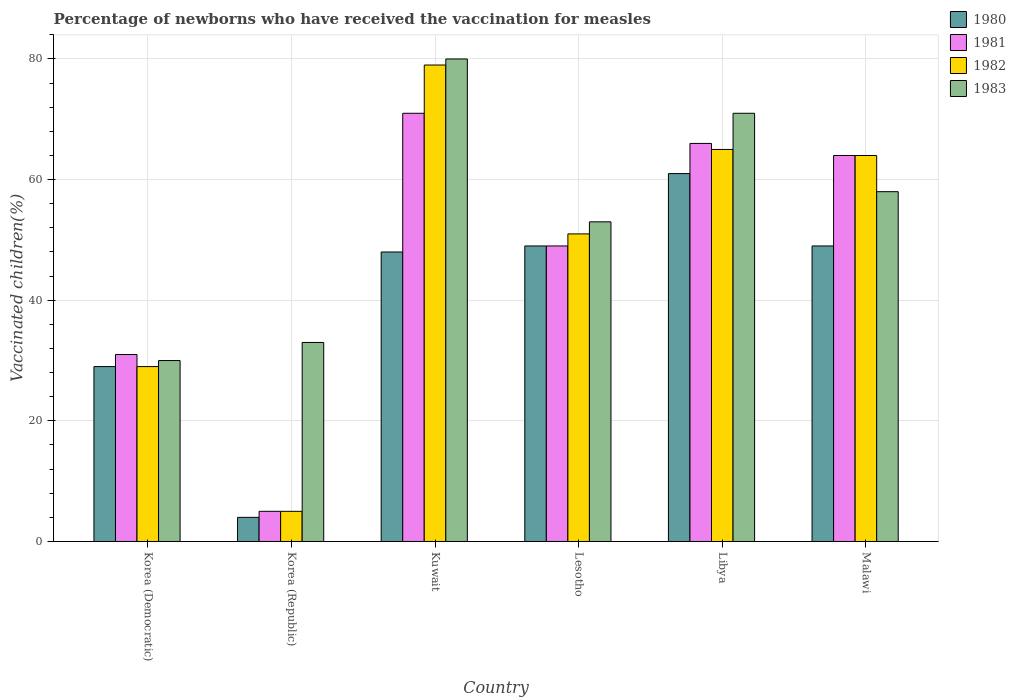How many different coloured bars are there?
Your response must be concise. 4. How many bars are there on the 6th tick from the right?
Your answer should be very brief. 4. What is the label of the 4th group of bars from the left?
Offer a very short reply. Lesotho. In how many cases, is the number of bars for a given country not equal to the number of legend labels?
Your response must be concise. 0. What is the percentage of vaccinated children in 1982 in Korea (Democratic)?
Provide a succinct answer. 29. Across all countries, what is the maximum percentage of vaccinated children in 1983?
Your answer should be compact. 80. In which country was the percentage of vaccinated children in 1982 maximum?
Your answer should be compact. Kuwait. What is the total percentage of vaccinated children in 1982 in the graph?
Ensure brevity in your answer.  293. What is the difference between the percentage of vaccinated children in 1982 in Korea (Democratic) and the percentage of vaccinated children in 1981 in Kuwait?
Make the answer very short. -42. What is the average percentage of vaccinated children in 1980 per country?
Provide a succinct answer. 40. What is the difference between the percentage of vaccinated children of/in 1981 and percentage of vaccinated children of/in 1983 in Korea (Democratic)?
Give a very brief answer. 1. What is the ratio of the percentage of vaccinated children in 1981 in Korea (Republic) to that in Lesotho?
Your answer should be compact. 0.1. Is the percentage of vaccinated children in 1980 in Korea (Democratic) less than that in Lesotho?
Offer a very short reply. Yes. Is the difference between the percentage of vaccinated children in 1981 in Korea (Democratic) and Kuwait greater than the difference between the percentage of vaccinated children in 1983 in Korea (Democratic) and Kuwait?
Make the answer very short. Yes. In how many countries, is the percentage of vaccinated children in 1982 greater than the average percentage of vaccinated children in 1982 taken over all countries?
Provide a short and direct response. 4. Is the sum of the percentage of vaccinated children in 1983 in Lesotho and Malawi greater than the maximum percentage of vaccinated children in 1981 across all countries?
Ensure brevity in your answer.  Yes. Is it the case that in every country, the sum of the percentage of vaccinated children in 1980 and percentage of vaccinated children in 1982 is greater than the percentage of vaccinated children in 1981?
Give a very brief answer. Yes. Are all the bars in the graph horizontal?
Keep it short and to the point. No. What is the difference between two consecutive major ticks on the Y-axis?
Your answer should be very brief. 20. Where does the legend appear in the graph?
Your answer should be very brief. Top right. How many legend labels are there?
Provide a succinct answer. 4. How are the legend labels stacked?
Offer a terse response. Vertical. What is the title of the graph?
Make the answer very short. Percentage of newborns who have received the vaccination for measles. What is the label or title of the Y-axis?
Your response must be concise. Vaccinated children(%). What is the Vaccinated children(%) in 1980 in Korea (Republic)?
Provide a short and direct response. 4. What is the Vaccinated children(%) of 1982 in Korea (Republic)?
Your answer should be compact. 5. What is the Vaccinated children(%) in 1982 in Kuwait?
Ensure brevity in your answer.  79. What is the Vaccinated children(%) in 1983 in Kuwait?
Make the answer very short. 80. What is the Vaccinated children(%) in 1981 in Lesotho?
Ensure brevity in your answer.  49. What is the Vaccinated children(%) of 1982 in Lesotho?
Ensure brevity in your answer.  51. What is the Vaccinated children(%) of 1980 in Libya?
Your answer should be very brief. 61. What is the Vaccinated children(%) in 1981 in Libya?
Your answer should be compact. 66. What is the Vaccinated children(%) in 1980 in Malawi?
Give a very brief answer. 49. What is the Vaccinated children(%) of 1982 in Malawi?
Your response must be concise. 64. Across all countries, what is the maximum Vaccinated children(%) of 1981?
Your answer should be very brief. 71. Across all countries, what is the maximum Vaccinated children(%) in 1982?
Provide a succinct answer. 79. Across all countries, what is the maximum Vaccinated children(%) of 1983?
Give a very brief answer. 80. Across all countries, what is the minimum Vaccinated children(%) in 1981?
Ensure brevity in your answer.  5. Across all countries, what is the minimum Vaccinated children(%) in 1982?
Ensure brevity in your answer.  5. Across all countries, what is the minimum Vaccinated children(%) of 1983?
Offer a very short reply. 30. What is the total Vaccinated children(%) of 1980 in the graph?
Your response must be concise. 240. What is the total Vaccinated children(%) in 1981 in the graph?
Keep it short and to the point. 286. What is the total Vaccinated children(%) of 1982 in the graph?
Make the answer very short. 293. What is the total Vaccinated children(%) in 1983 in the graph?
Make the answer very short. 325. What is the difference between the Vaccinated children(%) in 1982 in Korea (Democratic) and that in Korea (Republic)?
Your answer should be compact. 24. What is the difference between the Vaccinated children(%) in 1980 in Korea (Democratic) and that in Kuwait?
Provide a succinct answer. -19. What is the difference between the Vaccinated children(%) in 1980 in Korea (Democratic) and that in Libya?
Your response must be concise. -32. What is the difference between the Vaccinated children(%) of 1981 in Korea (Democratic) and that in Libya?
Give a very brief answer. -35. What is the difference between the Vaccinated children(%) of 1982 in Korea (Democratic) and that in Libya?
Offer a terse response. -36. What is the difference between the Vaccinated children(%) of 1983 in Korea (Democratic) and that in Libya?
Your answer should be compact. -41. What is the difference between the Vaccinated children(%) of 1980 in Korea (Democratic) and that in Malawi?
Give a very brief answer. -20. What is the difference between the Vaccinated children(%) of 1981 in Korea (Democratic) and that in Malawi?
Offer a terse response. -33. What is the difference between the Vaccinated children(%) in 1982 in Korea (Democratic) and that in Malawi?
Keep it short and to the point. -35. What is the difference between the Vaccinated children(%) in 1983 in Korea (Democratic) and that in Malawi?
Provide a succinct answer. -28. What is the difference between the Vaccinated children(%) of 1980 in Korea (Republic) and that in Kuwait?
Your response must be concise. -44. What is the difference between the Vaccinated children(%) of 1981 in Korea (Republic) and that in Kuwait?
Offer a very short reply. -66. What is the difference between the Vaccinated children(%) in 1982 in Korea (Republic) and that in Kuwait?
Offer a very short reply. -74. What is the difference between the Vaccinated children(%) in 1983 in Korea (Republic) and that in Kuwait?
Ensure brevity in your answer.  -47. What is the difference between the Vaccinated children(%) in 1980 in Korea (Republic) and that in Lesotho?
Keep it short and to the point. -45. What is the difference between the Vaccinated children(%) in 1981 in Korea (Republic) and that in Lesotho?
Offer a very short reply. -44. What is the difference between the Vaccinated children(%) in 1982 in Korea (Republic) and that in Lesotho?
Make the answer very short. -46. What is the difference between the Vaccinated children(%) in 1983 in Korea (Republic) and that in Lesotho?
Your response must be concise. -20. What is the difference between the Vaccinated children(%) of 1980 in Korea (Republic) and that in Libya?
Provide a short and direct response. -57. What is the difference between the Vaccinated children(%) of 1981 in Korea (Republic) and that in Libya?
Ensure brevity in your answer.  -61. What is the difference between the Vaccinated children(%) in 1982 in Korea (Republic) and that in Libya?
Provide a succinct answer. -60. What is the difference between the Vaccinated children(%) of 1983 in Korea (Republic) and that in Libya?
Offer a terse response. -38. What is the difference between the Vaccinated children(%) of 1980 in Korea (Republic) and that in Malawi?
Offer a terse response. -45. What is the difference between the Vaccinated children(%) in 1981 in Korea (Republic) and that in Malawi?
Your answer should be compact. -59. What is the difference between the Vaccinated children(%) in 1982 in Korea (Republic) and that in Malawi?
Your answer should be compact. -59. What is the difference between the Vaccinated children(%) of 1983 in Korea (Republic) and that in Malawi?
Offer a very short reply. -25. What is the difference between the Vaccinated children(%) of 1982 in Kuwait and that in Lesotho?
Offer a terse response. 28. What is the difference between the Vaccinated children(%) in 1983 in Kuwait and that in Lesotho?
Give a very brief answer. 27. What is the difference between the Vaccinated children(%) of 1982 in Kuwait and that in Libya?
Provide a succinct answer. 14. What is the difference between the Vaccinated children(%) of 1980 in Kuwait and that in Malawi?
Your response must be concise. -1. What is the difference between the Vaccinated children(%) in 1981 in Kuwait and that in Malawi?
Provide a succinct answer. 7. What is the difference between the Vaccinated children(%) in 1982 in Kuwait and that in Malawi?
Provide a short and direct response. 15. What is the difference between the Vaccinated children(%) of 1983 in Kuwait and that in Malawi?
Provide a short and direct response. 22. What is the difference between the Vaccinated children(%) of 1980 in Lesotho and that in Libya?
Give a very brief answer. -12. What is the difference between the Vaccinated children(%) of 1982 in Lesotho and that in Malawi?
Ensure brevity in your answer.  -13. What is the difference between the Vaccinated children(%) of 1981 in Libya and that in Malawi?
Offer a terse response. 2. What is the difference between the Vaccinated children(%) in 1983 in Libya and that in Malawi?
Give a very brief answer. 13. What is the difference between the Vaccinated children(%) in 1980 in Korea (Democratic) and the Vaccinated children(%) in 1982 in Korea (Republic)?
Provide a short and direct response. 24. What is the difference between the Vaccinated children(%) in 1980 in Korea (Democratic) and the Vaccinated children(%) in 1983 in Korea (Republic)?
Make the answer very short. -4. What is the difference between the Vaccinated children(%) of 1981 in Korea (Democratic) and the Vaccinated children(%) of 1982 in Korea (Republic)?
Your answer should be compact. 26. What is the difference between the Vaccinated children(%) in 1981 in Korea (Democratic) and the Vaccinated children(%) in 1983 in Korea (Republic)?
Your answer should be very brief. -2. What is the difference between the Vaccinated children(%) of 1980 in Korea (Democratic) and the Vaccinated children(%) of 1981 in Kuwait?
Your response must be concise. -42. What is the difference between the Vaccinated children(%) in 1980 in Korea (Democratic) and the Vaccinated children(%) in 1983 in Kuwait?
Your response must be concise. -51. What is the difference between the Vaccinated children(%) in 1981 in Korea (Democratic) and the Vaccinated children(%) in 1982 in Kuwait?
Give a very brief answer. -48. What is the difference between the Vaccinated children(%) of 1981 in Korea (Democratic) and the Vaccinated children(%) of 1983 in Kuwait?
Provide a succinct answer. -49. What is the difference between the Vaccinated children(%) of 1982 in Korea (Democratic) and the Vaccinated children(%) of 1983 in Kuwait?
Your response must be concise. -51. What is the difference between the Vaccinated children(%) in 1980 in Korea (Democratic) and the Vaccinated children(%) in 1981 in Lesotho?
Keep it short and to the point. -20. What is the difference between the Vaccinated children(%) of 1980 in Korea (Democratic) and the Vaccinated children(%) of 1983 in Lesotho?
Your answer should be very brief. -24. What is the difference between the Vaccinated children(%) of 1980 in Korea (Democratic) and the Vaccinated children(%) of 1981 in Libya?
Give a very brief answer. -37. What is the difference between the Vaccinated children(%) in 1980 in Korea (Democratic) and the Vaccinated children(%) in 1982 in Libya?
Your answer should be compact. -36. What is the difference between the Vaccinated children(%) in 1980 in Korea (Democratic) and the Vaccinated children(%) in 1983 in Libya?
Offer a very short reply. -42. What is the difference between the Vaccinated children(%) in 1981 in Korea (Democratic) and the Vaccinated children(%) in 1982 in Libya?
Provide a short and direct response. -34. What is the difference between the Vaccinated children(%) in 1982 in Korea (Democratic) and the Vaccinated children(%) in 1983 in Libya?
Your answer should be compact. -42. What is the difference between the Vaccinated children(%) in 1980 in Korea (Democratic) and the Vaccinated children(%) in 1981 in Malawi?
Keep it short and to the point. -35. What is the difference between the Vaccinated children(%) in 1980 in Korea (Democratic) and the Vaccinated children(%) in 1982 in Malawi?
Offer a terse response. -35. What is the difference between the Vaccinated children(%) of 1980 in Korea (Democratic) and the Vaccinated children(%) of 1983 in Malawi?
Offer a terse response. -29. What is the difference between the Vaccinated children(%) of 1981 in Korea (Democratic) and the Vaccinated children(%) of 1982 in Malawi?
Make the answer very short. -33. What is the difference between the Vaccinated children(%) of 1981 in Korea (Democratic) and the Vaccinated children(%) of 1983 in Malawi?
Offer a terse response. -27. What is the difference between the Vaccinated children(%) of 1980 in Korea (Republic) and the Vaccinated children(%) of 1981 in Kuwait?
Provide a short and direct response. -67. What is the difference between the Vaccinated children(%) in 1980 in Korea (Republic) and the Vaccinated children(%) in 1982 in Kuwait?
Offer a terse response. -75. What is the difference between the Vaccinated children(%) of 1980 in Korea (Republic) and the Vaccinated children(%) of 1983 in Kuwait?
Your answer should be compact. -76. What is the difference between the Vaccinated children(%) in 1981 in Korea (Republic) and the Vaccinated children(%) in 1982 in Kuwait?
Your response must be concise. -74. What is the difference between the Vaccinated children(%) in 1981 in Korea (Republic) and the Vaccinated children(%) in 1983 in Kuwait?
Your answer should be compact. -75. What is the difference between the Vaccinated children(%) in 1982 in Korea (Republic) and the Vaccinated children(%) in 1983 in Kuwait?
Provide a short and direct response. -75. What is the difference between the Vaccinated children(%) of 1980 in Korea (Republic) and the Vaccinated children(%) of 1981 in Lesotho?
Give a very brief answer. -45. What is the difference between the Vaccinated children(%) of 1980 in Korea (Republic) and the Vaccinated children(%) of 1982 in Lesotho?
Provide a succinct answer. -47. What is the difference between the Vaccinated children(%) of 1980 in Korea (Republic) and the Vaccinated children(%) of 1983 in Lesotho?
Ensure brevity in your answer.  -49. What is the difference between the Vaccinated children(%) in 1981 in Korea (Republic) and the Vaccinated children(%) in 1982 in Lesotho?
Your answer should be compact. -46. What is the difference between the Vaccinated children(%) of 1981 in Korea (Republic) and the Vaccinated children(%) of 1983 in Lesotho?
Make the answer very short. -48. What is the difference between the Vaccinated children(%) in 1982 in Korea (Republic) and the Vaccinated children(%) in 1983 in Lesotho?
Your answer should be compact. -48. What is the difference between the Vaccinated children(%) of 1980 in Korea (Republic) and the Vaccinated children(%) of 1981 in Libya?
Provide a short and direct response. -62. What is the difference between the Vaccinated children(%) of 1980 in Korea (Republic) and the Vaccinated children(%) of 1982 in Libya?
Your answer should be compact. -61. What is the difference between the Vaccinated children(%) in 1980 in Korea (Republic) and the Vaccinated children(%) in 1983 in Libya?
Give a very brief answer. -67. What is the difference between the Vaccinated children(%) in 1981 in Korea (Republic) and the Vaccinated children(%) in 1982 in Libya?
Give a very brief answer. -60. What is the difference between the Vaccinated children(%) of 1981 in Korea (Republic) and the Vaccinated children(%) of 1983 in Libya?
Your answer should be very brief. -66. What is the difference between the Vaccinated children(%) in 1982 in Korea (Republic) and the Vaccinated children(%) in 1983 in Libya?
Provide a succinct answer. -66. What is the difference between the Vaccinated children(%) in 1980 in Korea (Republic) and the Vaccinated children(%) in 1981 in Malawi?
Keep it short and to the point. -60. What is the difference between the Vaccinated children(%) in 1980 in Korea (Republic) and the Vaccinated children(%) in 1982 in Malawi?
Provide a succinct answer. -60. What is the difference between the Vaccinated children(%) in 1980 in Korea (Republic) and the Vaccinated children(%) in 1983 in Malawi?
Your answer should be compact. -54. What is the difference between the Vaccinated children(%) in 1981 in Korea (Republic) and the Vaccinated children(%) in 1982 in Malawi?
Your answer should be compact. -59. What is the difference between the Vaccinated children(%) of 1981 in Korea (Republic) and the Vaccinated children(%) of 1983 in Malawi?
Provide a succinct answer. -53. What is the difference between the Vaccinated children(%) in 1982 in Korea (Republic) and the Vaccinated children(%) in 1983 in Malawi?
Your answer should be very brief. -53. What is the difference between the Vaccinated children(%) in 1980 in Kuwait and the Vaccinated children(%) in 1982 in Lesotho?
Your answer should be very brief. -3. What is the difference between the Vaccinated children(%) of 1981 in Kuwait and the Vaccinated children(%) of 1983 in Lesotho?
Your response must be concise. 18. What is the difference between the Vaccinated children(%) of 1982 in Kuwait and the Vaccinated children(%) of 1983 in Lesotho?
Give a very brief answer. 26. What is the difference between the Vaccinated children(%) in 1980 in Kuwait and the Vaccinated children(%) in 1983 in Libya?
Keep it short and to the point. -23. What is the difference between the Vaccinated children(%) of 1982 in Kuwait and the Vaccinated children(%) of 1983 in Libya?
Offer a very short reply. 8. What is the difference between the Vaccinated children(%) of 1980 in Kuwait and the Vaccinated children(%) of 1981 in Malawi?
Your answer should be compact. -16. What is the difference between the Vaccinated children(%) in 1981 in Kuwait and the Vaccinated children(%) in 1982 in Malawi?
Keep it short and to the point. 7. What is the difference between the Vaccinated children(%) of 1981 in Kuwait and the Vaccinated children(%) of 1983 in Malawi?
Give a very brief answer. 13. What is the difference between the Vaccinated children(%) of 1982 in Kuwait and the Vaccinated children(%) of 1983 in Malawi?
Provide a short and direct response. 21. What is the difference between the Vaccinated children(%) of 1980 in Lesotho and the Vaccinated children(%) of 1983 in Libya?
Your answer should be very brief. -22. What is the difference between the Vaccinated children(%) of 1981 in Lesotho and the Vaccinated children(%) of 1982 in Libya?
Your response must be concise. -16. What is the difference between the Vaccinated children(%) of 1980 in Lesotho and the Vaccinated children(%) of 1981 in Malawi?
Provide a short and direct response. -15. What is the difference between the Vaccinated children(%) in 1980 in Lesotho and the Vaccinated children(%) in 1983 in Malawi?
Offer a terse response. -9. What is the difference between the Vaccinated children(%) of 1982 in Lesotho and the Vaccinated children(%) of 1983 in Malawi?
Keep it short and to the point. -7. What is the difference between the Vaccinated children(%) in 1980 in Libya and the Vaccinated children(%) in 1982 in Malawi?
Make the answer very short. -3. What is the difference between the Vaccinated children(%) in 1982 in Libya and the Vaccinated children(%) in 1983 in Malawi?
Offer a very short reply. 7. What is the average Vaccinated children(%) in 1981 per country?
Offer a terse response. 47.67. What is the average Vaccinated children(%) in 1982 per country?
Make the answer very short. 48.83. What is the average Vaccinated children(%) in 1983 per country?
Offer a very short reply. 54.17. What is the difference between the Vaccinated children(%) of 1980 and Vaccinated children(%) of 1981 in Korea (Democratic)?
Ensure brevity in your answer.  -2. What is the difference between the Vaccinated children(%) of 1980 and Vaccinated children(%) of 1983 in Korea (Democratic)?
Make the answer very short. -1. What is the difference between the Vaccinated children(%) of 1981 and Vaccinated children(%) of 1982 in Korea (Democratic)?
Your answer should be very brief. 2. What is the difference between the Vaccinated children(%) of 1981 and Vaccinated children(%) of 1983 in Korea (Democratic)?
Make the answer very short. 1. What is the difference between the Vaccinated children(%) of 1980 and Vaccinated children(%) of 1982 in Korea (Republic)?
Provide a short and direct response. -1. What is the difference between the Vaccinated children(%) in 1980 and Vaccinated children(%) in 1983 in Korea (Republic)?
Provide a short and direct response. -29. What is the difference between the Vaccinated children(%) of 1980 and Vaccinated children(%) of 1982 in Kuwait?
Make the answer very short. -31. What is the difference between the Vaccinated children(%) in 1980 and Vaccinated children(%) in 1983 in Kuwait?
Offer a very short reply. -32. What is the difference between the Vaccinated children(%) of 1981 and Vaccinated children(%) of 1982 in Kuwait?
Keep it short and to the point. -8. What is the difference between the Vaccinated children(%) in 1980 and Vaccinated children(%) in 1981 in Lesotho?
Offer a very short reply. 0. What is the difference between the Vaccinated children(%) of 1980 and Vaccinated children(%) of 1983 in Libya?
Ensure brevity in your answer.  -10. What is the difference between the Vaccinated children(%) of 1981 and Vaccinated children(%) of 1983 in Libya?
Your answer should be compact. -5. What is the difference between the Vaccinated children(%) in 1980 and Vaccinated children(%) in 1981 in Malawi?
Your answer should be very brief. -15. What is the difference between the Vaccinated children(%) in 1980 and Vaccinated children(%) in 1982 in Malawi?
Provide a short and direct response. -15. What is the difference between the Vaccinated children(%) in 1981 and Vaccinated children(%) in 1982 in Malawi?
Give a very brief answer. 0. What is the difference between the Vaccinated children(%) of 1982 and Vaccinated children(%) of 1983 in Malawi?
Your answer should be compact. 6. What is the ratio of the Vaccinated children(%) in 1980 in Korea (Democratic) to that in Korea (Republic)?
Give a very brief answer. 7.25. What is the ratio of the Vaccinated children(%) of 1982 in Korea (Democratic) to that in Korea (Republic)?
Your response must be concise. 5.8. What is the ratio of the Vaccinated children(%) in 1983 in Korea (Democratic) to that in Korea (Republic)?
Make the answer very short. 0.91. What is the ratio of the Vaccinated children(%) in 1980 in Korea (Democratic) to that in Kuwait?
Your response must be concise. 0.6. What is the ratio of the Vaccinated children(%) in 1981 in Korea (Democratic) to that in Kuwait?
Offer a terse response. 0.44. What is the ratio of the Vaccinated children(%) in 1982 in Korea (Democratic) to that in Kuwait?
Keep it short and to the point. 0.37. What is the ratio of the Vaccinated children(%) in 1980 in Korea (Democratic) to that in Lesotho?
Offer a terse response. 0.59. What is the ratio of the Vaccinated children(%) of 1981 in Korea (Democratic) to that in Lesotho?
Ensure brevity in your answer.  0.63. What is the ratio of the Vaccinated children(%) of 1982 in Korea (Democratic) to that in Lesotho?
Give a very brief answer. 0.57. What is the ratio of the Vaccinated children(%) in 1983 in Korea (Democratic) to that in Lesotho?
Keep it short and to the point. 0.57. What is the ratio of the Vaccinated children(%) of 1980 in Korea (Democratic) to that in Libya?
Keep it short and to the point. 0.48. What is the ratio of the Vaccinated children(%) in 1981 in Korea (Democratic) to that in Libya?
Your response must be concise. 0.47. What is the ratio of the Vaccinated children(%) in 1982 in Korea (Democratic) to that in Libya?
Provide a short and direct response. 0.45. What is the ratio of the Vaccinated children(%) of 1983 in Korea (Democratic) to that in Libya?
Your answer should be very brief. 0.42. What is the ratio of the Vaccinated children(%) in 1980 in Korea (Democratic) to that in Malawi?
Make the answer very short. 0.59. What is the ratio of the Vaccinated children(%) of 1981 in Korea (Democratic) to that in Malawi?
Keep it short and to the point. 0.48. What is the ratio of the Vaccinated children(%) in 1982 in Korea (Democratic) to that in Malawi?
Offer a very short reply. 0.45. What is the ratio of the Vaccinated children(%) of 1983 in Korea (Democratic) to that in Malawi?
Give a very brief answer. 0.52. What is the ratio of the Vaccinated children(%) in 1980 in Korea (Republic) to that in Kuwait?
Your answer should be compact. 0.08. What is the ratio of the Vaccinated children(%) in 1981 in Korea (Republic) to that in Kuwait?
Provide a short and direct response. 0.07. What is the ratio of the Vaccinated children(%) of 1982 in Korea (Republic) to that in Kuwait?
Provide a succinct answer. 0.06. What is the ratio of the Vaccinated children(%) of 1983 in Korea (Republic) to that in Kuwait?
Offer a terse response. 0.41. What is the ratio of the Vaccinated children(%) of 1980 in Korea (Republic) to that in Lesotho?
Offer a terse response. 0.08. What is the ratio of the Vaccinated children(%) of 1981 in Korea (Republic) to that in Lesotho?
Your response must be concise. 0.1. What is the ratio of the Vaccinated children(%) in 1982 in Korea (Republic) to that in Lesotho?
Offer a terse response. 0.1. What is the ratio of the Vaccinated children(%) of 1983 in Korea (Republic) to that in Lesotho?
Offer a very short reply. 0.62. What is the ratio of the Vaccinated children(%) of 1980 in Korea (Republic) to that in Libya?
Your answer should be compact. 0.07. What is the ratio of the Vaccinated children(%) in 1981 in Korea (Republic) to that in Libya?
Offer a terse response. 0.08. What is the ratio of the Vaccinated children(%) of 1982 in Korea (Republic) to that in Libya?
Keep it short and to the point. 0.08. What is the ratio of the Vaccinated children(%) in 1983 in Korea (Republic) to that in Libya?
Ensure brevity in your answer.  0.46. What is the ratio of the Vaccinated children(%) in 1980 in Korea (Republic) to that in Malawi?
Your answer should be compact. 0.08. What is the ratio of the Vaccinated children(%) of 1981 in Korea (Republic) to that in Malawi?
Your answer should be compact. 0.08. What is the ratio of the Vaccinated children(%) of 1982 in Korea (Republic) to that in Malawi?
Make the answer very short. 0.08. What is the ratio of the Vaccinated children(%) in 1983 in Korea (Republic) to that in Malawi?
Your answer should be very brief. 0.57. What is the ratio of the Vaccinated children(%) in 1980 in Kuwait to that in Lesotho?
Provide a short and direct response. 0.98. What is the ratio of the Vaccinated children(%) in 1981 in Kuwait to that in Lesotho?
Your response must be concise. 1.45. What is the ratio of the Vaccinated children(%) in 1982 in Kuwait to that in Lesotho?
Provide a succinct answer. 1.55. What is the ratio of the Vaccinated children(%) of 1983 in Kuwait to that in Lesotho?
Make the answer very short. 1.51. What is the ratio of the Vaccinated children(%) in 1980 in Kuwait to that in Libya?
Your response must be concise. 0.79. What is the ratio of the Vaccinated children(%) of 1981 in Kuwait to that in Libya?
Your answer should be very brief. 1.08. What is the ratio of the Vaccinated children(%) in 1982 in Kuwait to that in Libya?
Offer a terse response. 1.22. What is the ratio of the Vaccinated children(%) of 1983 in Kuwait to that in Libya?
Your answer should be compact. 1.13. What is the ratio of the Vaccinated children(%) of 1980 in Kuwait to that in Malawi?
Your response must be concise. 0.98. What is the ratio of the Vaccinated children(%) in 1981 in Kuwait to that in Malawi?
Provide a succinct answer. 1.11. What is the ratio of the Vaccinated children(%) of 1982 in Kuwait to that in Malawi?
Ensure brevity in your answer.  1.23. What is the ratio of the Vaccinated children(%) in 1983 in Kuwait to that in Malawi?
Provide a short and direct response. 1.38. What is the ratio of the Vaccinated children(%) in 1980 in Lesotho to that in Libya?
Provide a succinct answer. 0.8. What is the ratio of the Vaccinated children(%) in 1981 in Lesotho to that in Libya?
Offer a very short reply. 0.74. What is the ratio of the Vaccinated children(%) of 1982 in Lesotho to that in Libya?
Offer a terse response. 0.78. What is the ratio of the Vaccinated children(%) in 1983 in Lesotho to that in Libya?
Your response must be concise. 0.75. What is the ratio of the Vaccinated children(%) of 1980 in Lesotho to that in Malawi?
Your response must be concise. 1. What is the ratio of the Vaccinated children(%) of 1981 in Lesotho to that in Malawi?
Keep it short and to the point. 0.77. What is the ratio of the Vaccinated children(%) in 1982 in Lesotho to that in Malawi?
Keep it short and to the point. 0.8. What is the ratio of the Vaccinated children(%) of 1983 in Lesotho to that in Malawi?
Offer a very short reply. 0.91. What is the ratio of the Vaccinated children(%) in 1980 in Libya to that in Malawi?
Give a very brief answer. 1.24. What is the ratio of the Vaccinated children(%) in 1981 in Libya to that in Malawi?
Provide a short and direct response. 1.03. What is the ratio of the Vaccinated children(%) in 1982 in Libya to that in Malawi?
Your answer should be compact. 1.02. What is the ratio of the Vaccinated children(%) of 1983 in Libya to that in Malawi?
Your response must be concise. 1.22. What is the difference between the highest and the second highest Vaccinated children(%) of 1981?
Give a very brief answer. 5. What is the difference between the highest and the lowest Vaccinated children(%) in 1981?
Provide a short and direct response. 66. What is the difference between the highest and the lowest Vaccinated children(%) in 1982?
Provide a succinct answer. 74. What is the difference between the highest and the lowest Vaccinated children(%) of 1983?
Your response must be concise. 50. 